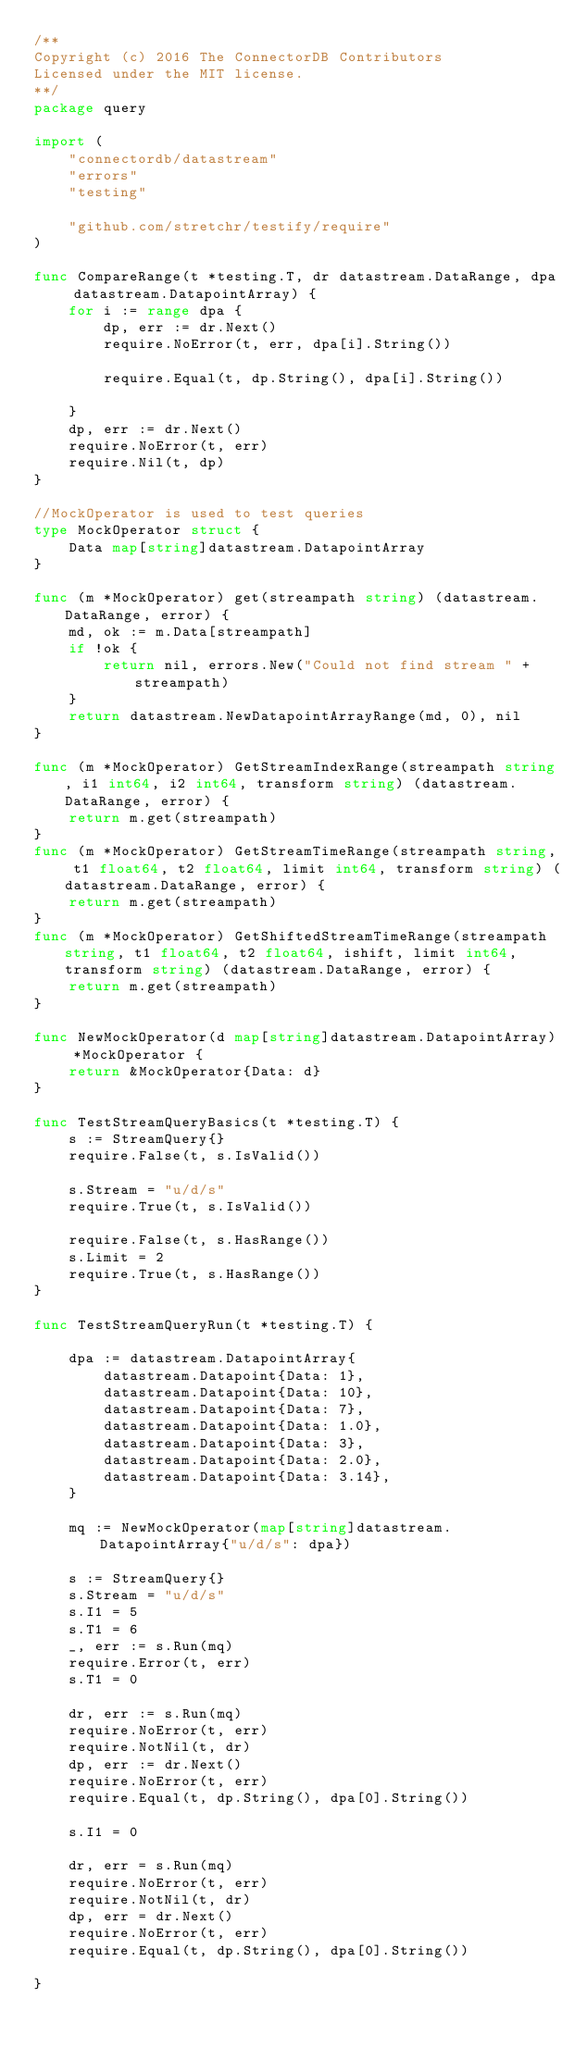<code> <loc_0><loc_0><loc_500><loc_500><_Go_>/**
Copyright (c) 2016 The ConnectorDB Contributors
Licensed under the MIT license.
**/
package query

import (
	"connectordb/datastream"
	"errors"
	"testing"

	"github.com/stretchr/testify/require"
)

func CompareRange(t *testing.T, dr datastream.DataRange, dpa datastream.DatapointArray) {
	for i := range dpa {
		dp, err := dr.Next()
		require.NoError(t, err, dpa[i].String())

		require.Equal(t, dp.String(), dpa[i].String())

	}
	dp, err := dr.Next()
	require.NoError(t, err)
	require.Nil(t, dp)
}

//MockOperator is used to test queries
type MockOperator struct {
	Data map[string]datastream.DatapointArray
}

func (m *MockOperator) get(streampath string) (datastream.DataRange, error) {
	md, ok := m.Data[streampath]
	if !ok {
		return nil, errors.New("Could not find stream " + streampath)
	}
	return datastream.NewDatapointArrayRange(md, 0), nil
}

func (m *MockOperator) GetStreamIndexRange(streampath string, i1 int64, i2 int64, transform string) (datastream.DataRange, error) {
	return m.get(streampath)
}
func (m *MockOperator) GetStreamTimeRange(streampath string, t1 float64, t2 float64, limit int64, transform string) (datastream.DataRange, error) {
	return m.get(streampath)
}
func (m *MockOperator) GetShiftedStreamTimeRange(streampath string, t1 float64, t2 float64, ishift, limit int64, transform string) (datastream.DataRange, error) {
	return m.get(streampath)
}

func NewMockOperator(d map[string]datastream.DatapointArray) *MockOperator {
	return &MockOperator{Data: d}
}

func TestStreamQueryBasics(t *testing.T) {
	s := StreamQuery{}
	require.False(t, s.IsValid())

	s.Stream = "u/d/s"
	require.True(t, s.IsValid())

	require.False(t, s.HasRange())
	s.Limit = 2
	require.True(t, s.HasRange())
}

func TestStreamQueryRun(t *testing.T) {

	dpa := datastream.DatapointArray{
		datastream.Datapoint{Data: 1},
		datastream.Datapoint{Data: 10},
		datastream.Datapoint{Data: 7},
		datastream.Datapoint{Data: 1.0},
		datastream.Datapoint{Data: 3},
		datastream.Datapoint{Data: 2.0},
		datastream.Datapoint{Data: 3.14},
	}

	mq := NewMockOperator(map[string]datastream.DatapointArray{"u/d/s": dpa})

	s := StreamQuery{}
	s.Stream = "u/d/s"
	s.I1 = 5
	s.T1 = 6
	_, err := s.Run(mq)
	require.Error(t, err)
	s.T1 = 0

	dr, err := s.Run(mq)
	require.NoError(t, err)
	require.NotNil(t, dr)
	dp, err := dr.Next()
	require.NoError(t, err)
	require.Equal(t, dp.String(), dpa[0].String())

	s.I1 = 0

	dr, err = s.Run(mq)
	require.NoError(t, err)
	require.NotNil(t, dr)
	dp, err = dr.Next()
	require.NoError(t, err)
	require.Equal(t, dp.String(), dpa[0].String())

}
</code> 